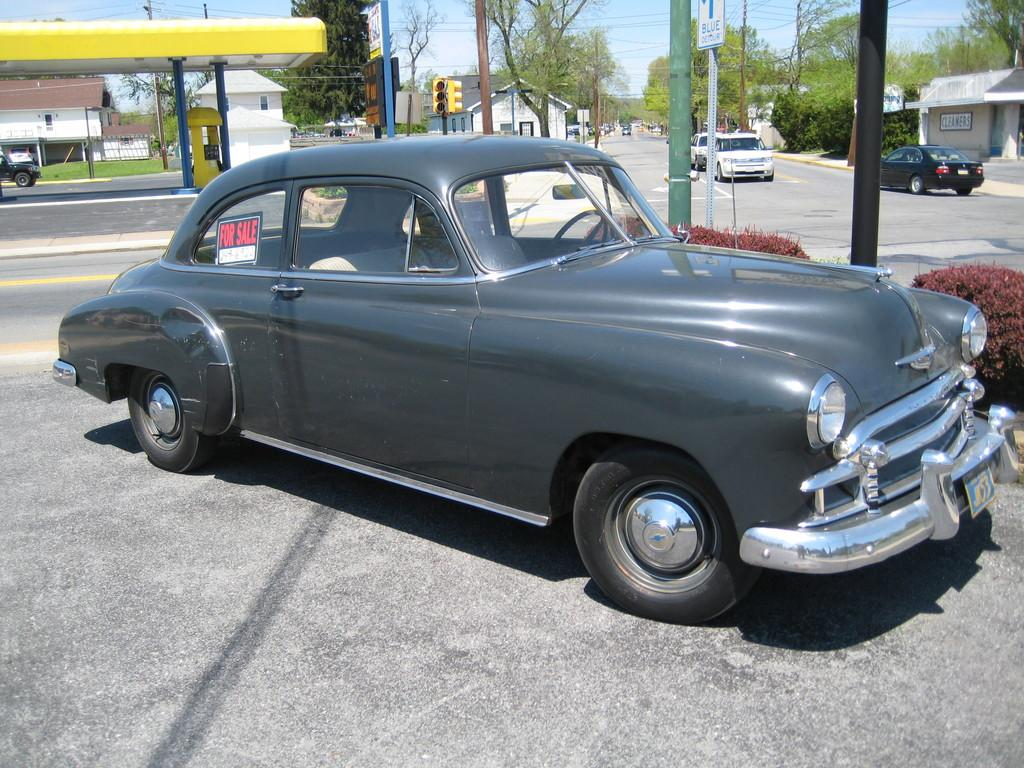What is located on the left side of the image? There is a car parked on the left side of the image. What type of vegetation can be seen in the image? There are plants and trees in the image. What architectural features are present in the image? There are poles and buildings in the image. What is the condition of the sky in the image? The sky is clear in the image. Can you tell me how many tents are set up in the image? There are no tents present in the image. What type of agreement is being discussed in the image? There is no discussion or agreement depicted in the image. 